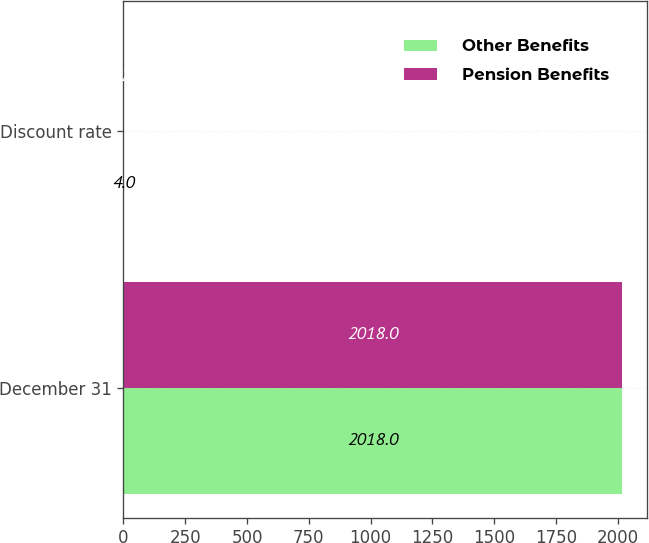<chart> <loc_0><loc_0><loc_500><loc_500><stacked_bar_chart><ecel><fcel>December 31<fcel>Discount rate<nl><fcel>Other Benefits<fcel>2018<fcel>4<nl><fcel>Pension Benefits<fcel>2018<fcel>4.25<nl></chart> 